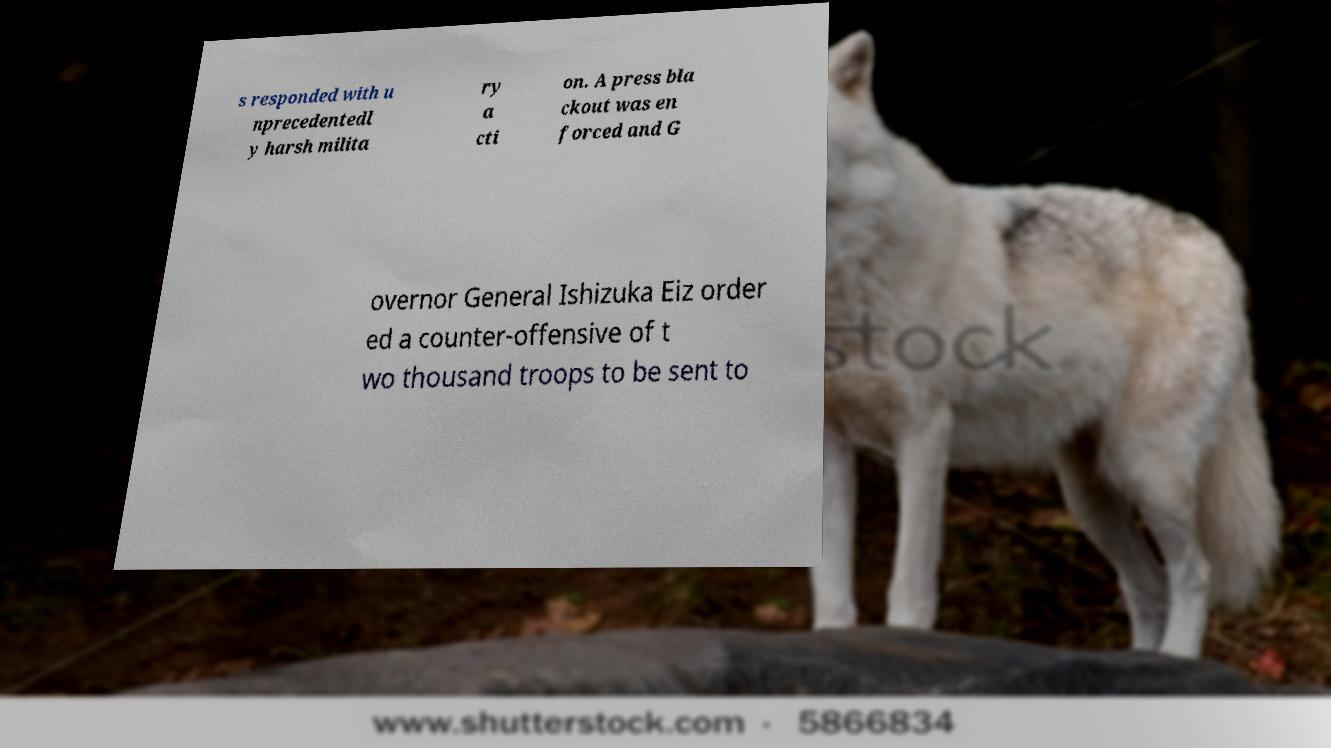Please read and relay the text visible in this image. What does it say? s responded with u nprecedentedl y harsh milita ry a cti on. A press bla ckout was en forced and G overnor General Ishizuka Eiz order ed a counter-offensive of t wo thousand troops to be sent to 